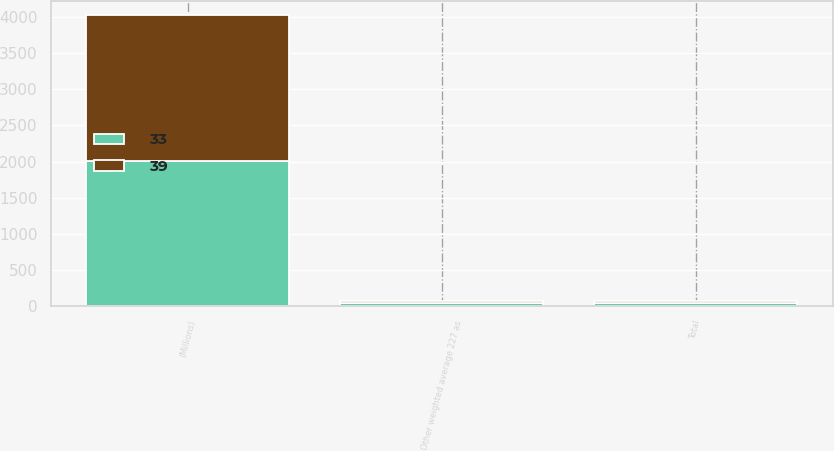Convert chart. <chart><loc_0><loc_0><loc_500><loc_500><stacked_bar_chart><ecel><fcel>(Millions)<fcel>Other weighted average 227 as<fcel>Total<nl><fcel>33<fcel>2012<fcel>39<fcel>39<nl><fcel>39<fcel>2011<fcel>33<fcel>33<nl></chart> 